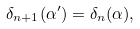<formula> <loc_0><loc_0><loc_500><loc_500>\delta _ { n + 1 } ( \alpha ^ { \prime } ) = \delta _ { n } ( \alpha ) ,</formula> 